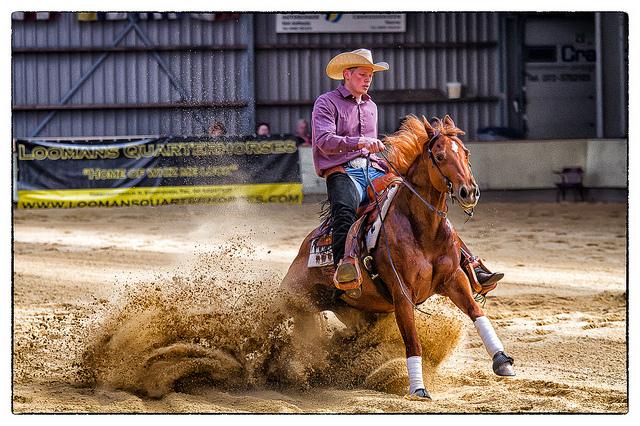What kind of hat is this person wearing?
Answer briefly. Cowboy hat. Is the horse speeding up or slowing down?
Give a very brief answer. Slowing down. Is the horse hurt?
Answer briefly. No. 